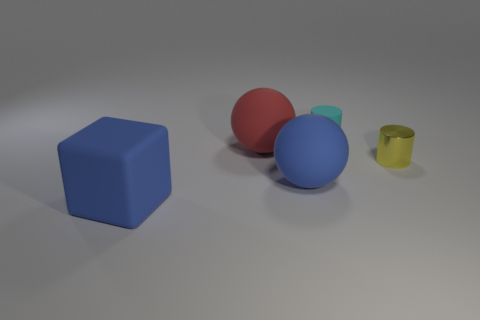Are the big blue sphere and the red thing that is to the left of the cyan thing made of the same material?
Make the answer very short. Yes. Are there more blue objects on the right side of the yellow shiny cylinder than blue blocks?
Ensure brevity in your answer.  No. Is there any other thing that is the same size as the matte block?
Offer a terse response. Yes. There is a metal thing; is it the same color as the big sphere in front of the red matte thing?
Your answer should be compact. No. Are there an equal number of small yellow metallic cylinders that are to the left of the yellow metal cylinder and tiny yellow things that are behind the small matte cylinder?
Keep it short and to the point. Yes. What material is the blue object behind the big blue block?
Offer a very short reply. Rubber. How many things are either things that are right of the tiny cyan thing or rubber blocks?
Offer a terse response. 2. What number of other things are the same shape as the small yellow thing?
Your answer should be very brief. 1. Does the tiny thing that is to the left of the metallic thing have the same shape as the yellow object?
Offer a terse response. Yes. Are there any large blue rubber things right of the large matte cube?
Your answer should be compact. Yes. 